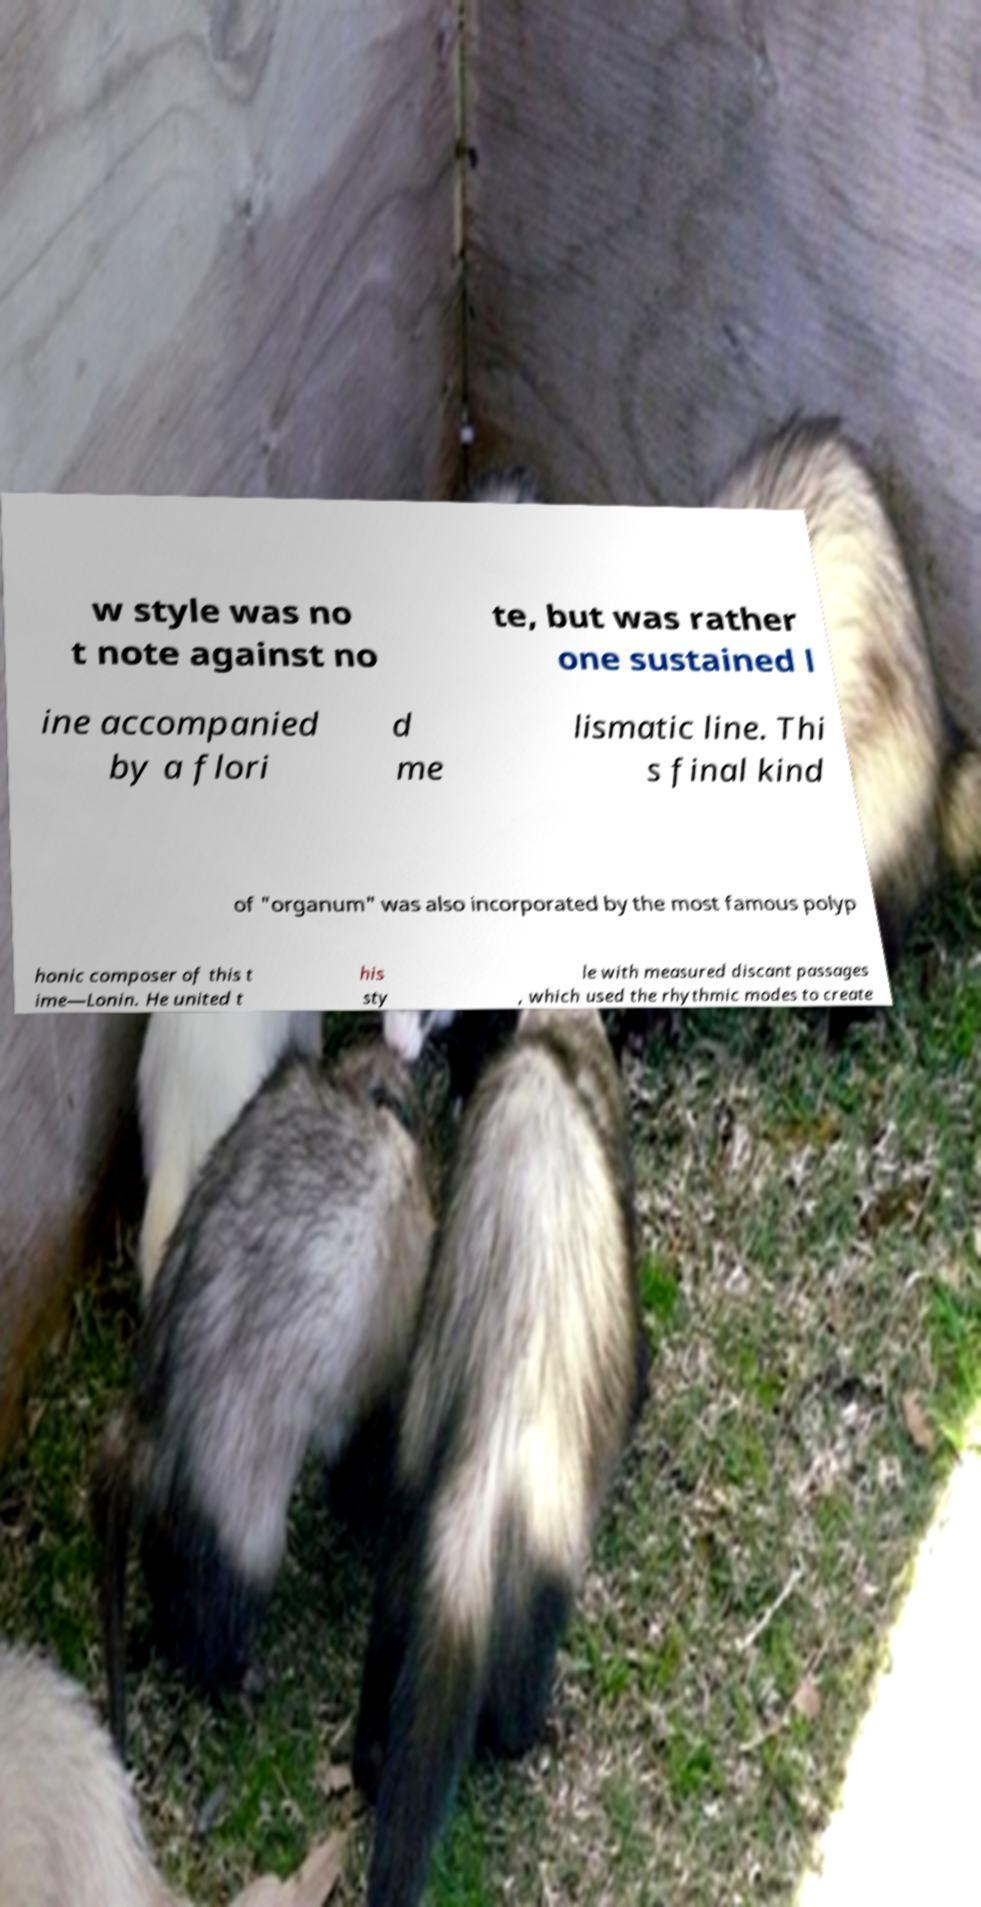For documentation purposes, I need the text within this image transcribed. Could you provide that? w style was no t note against no te, but was rather one sustained l ine accompanied by a flori d me lismatic line. Thi s final kind of "organum" was also incorporated by the most famous polyp honic composer of this t ime—Lonin. He united t his sty le with measured discant passages , which used the rhythmic modes to create 